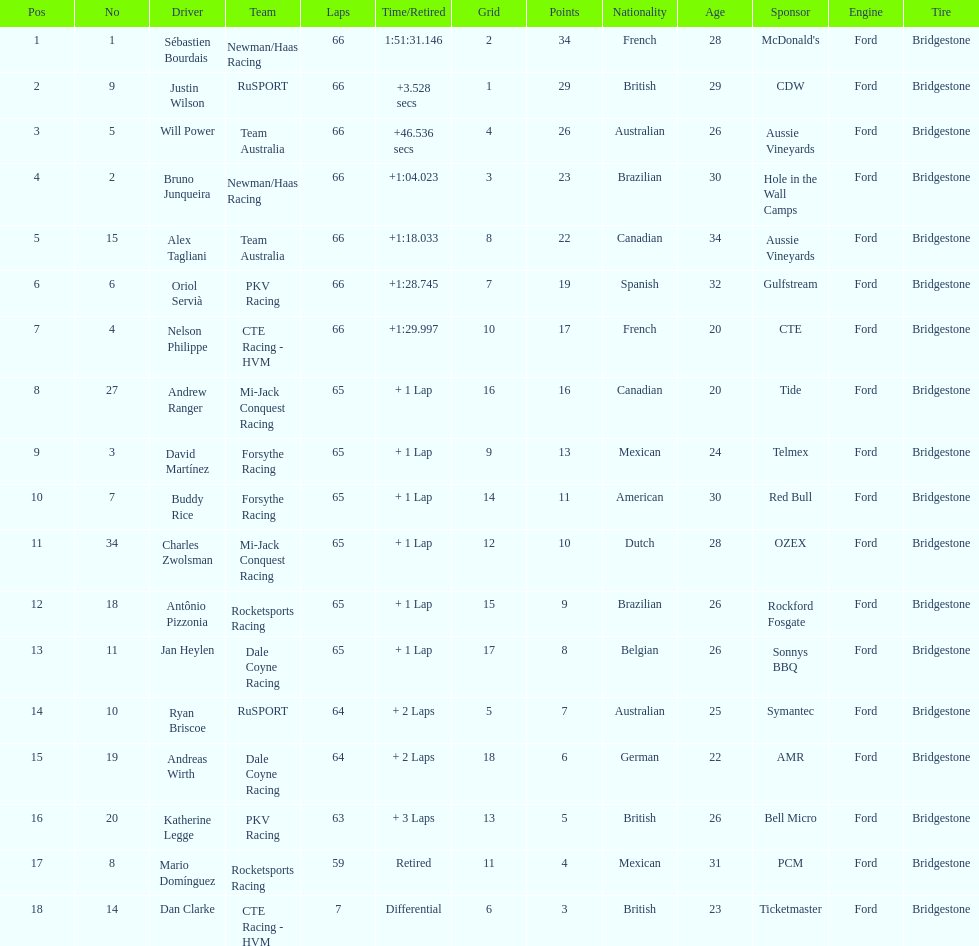Which country is represented by the most drivers? United Kingdom. 